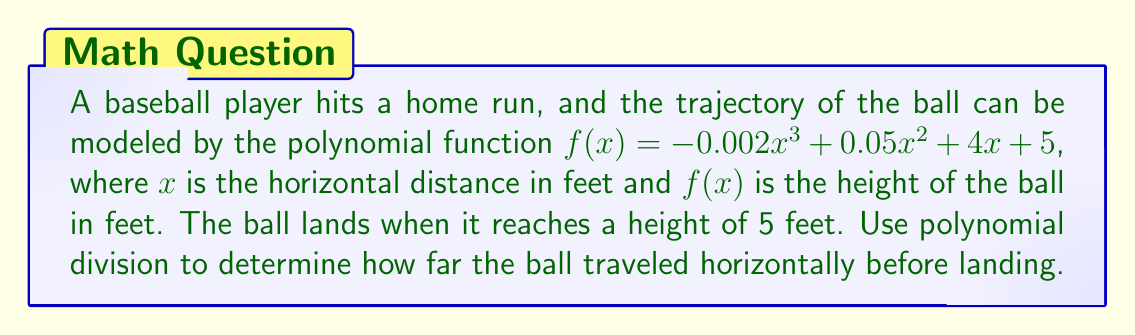What is the answer to this math problem? To solve this problem, we need to follow these steps:

1) The ball lands when $f(x) = 5$. So, we need to find the roots of the equation:
   $-0.002x^3 + 0.05x^2 + 4x + 5 - 5 = 0$
   $-0.002x^3 + 0.05x^2 + 4x = 0$

2) Factor out the greatest common factor:
   $x(-0.002x^2 + 0.05x + 4) = 0$

3) One root is clearly $x = 0$. For the other roots, we need to solve:
   $-0.002x^2 + 0.05x + 4 = 0$

4) We can solve this using the quadratic formula, but as a new baseball fan, it's easier to use polynomial division to find the other root.

5) Let's divide $-0.002x^3 + 0.05x^2 + 4x$ by $(x - 0)$:

   $$
   \begin{array}{r}
   -0.002x^2 + 0.05x + 4 \\
   x \enclose{longdiv}{-0.002x^3 + 0.05x^2 + 4x + 0} \\
   \underline{-0.002x^3 \phantom{+ 0.05x^2 + 4x + 0}} \\
   0.05x^2 + 4x + 0 \\
   \underline{0.05x^2 \phantom{+ 4x + 0}} \\
   4x + 0 \\
   \underline{4x \phantom{+ 0}} \\
   0
   \end{array}
   $$

6) The result of the division is $-0.002x^2 + 0.05x + 4$, which is the quadratic we found in step 3.

7) The roots of this quadratic are the other two solutions to our original equation. We can find these using the quadratic formula:

   $x = \frac{-b \pm \sqrt{b^2 - 4ac}}{2a}$

   Where $a = -0.002$, $b = 0.05$, and $c = 4$

8) Plugging in these values:

   $x = \frac{-0.05 \pm \sqrt{0.05^2 - 4(-0.002)(4)}}{2(-0.002)}$

9) Simplifying:

   $x = \frac{-0.05 \pm \sqrt{0.0025 + 0.032}}{-0.004} = \frac{-0.05 \pm \sqrt{0.0345}}{-0.004} = \frac{-0.05 \pm 0.1857}{-0.004}$

10) This gives us two solutions:
    $x_1 = \frac{-0.05 + 0.1857}{-0.004} = -33.93$
    $x_2 = \frac{-0.05 - 0.1857}{-0.004} = 58.93$

11) Since distance can't be negative, we discard the negative solution. The ball travels 58.93 feet horizontally before landing.
Answer: The ball traveled approximately 58.93 feet horizontally before landing. 